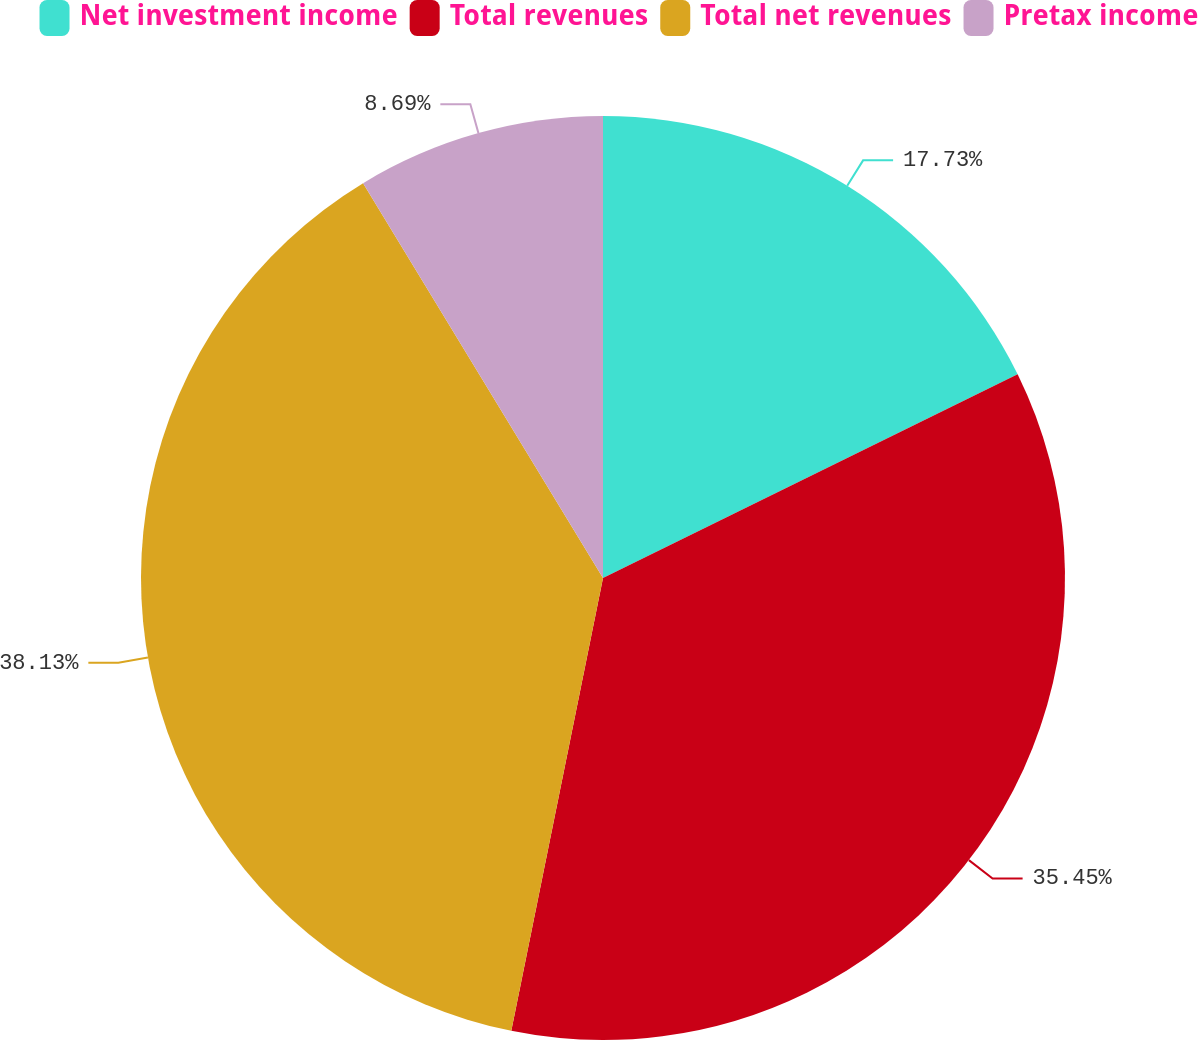Convert chart. <chart><loc_0><loc_0><loc_500><loc_500><pie_chart><fcel>Net investment income<fcel>Total revenues<fcel>Total net revenues<fcel>Pretax income<nl><fcel>17.73%<fcel>35.45%<fcel>38.13%<fcel>8.69%<nl></chart> 